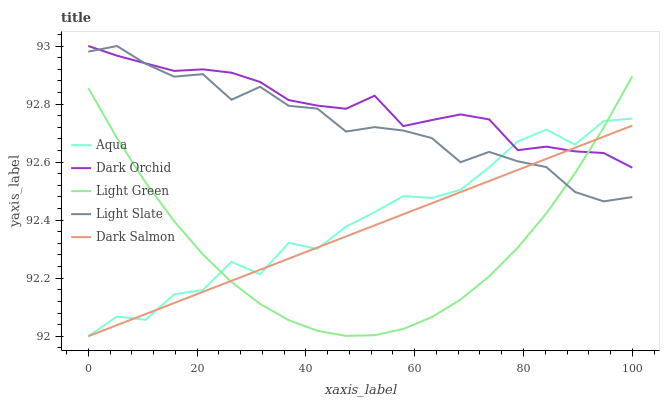Does Light Green have the minimum area under the curve?
Answer yes or no. Yes. Does Dark Orchid have the maximum area under the curve?
Answer yes or no. Yes. Does Aqua have the minimum area under the curve?
Answer yes or no. No. Does Aqua have the maximum area under the curve?
Answer yes or no. No. Is Dark Salmon the smoothest?
Answer yes or no. Yes. Is Aqua the roughest?
Answer yes or no. Yes. Is Light Green the smoothest?
Answer yes or no. No. Is Light Green the roughest?
Answer yes or no. No. Does Aqua have the lowest value?
Answer yes or no. Yes. Does Light Green have the lowest value?
Answer yes or no. No. Does Dark Orchid have the highest value?
Answer yes or no. Yes. Does Aqua have the highest value?
Answer yes or no. No. Does Light Slate intersect Light Green?
Answer yes or no. Yes. Is Light Slate less than Light Green?
Answer yes or no. No. Is Light Slate greater than Light Green?
Answer yes or no. No. 